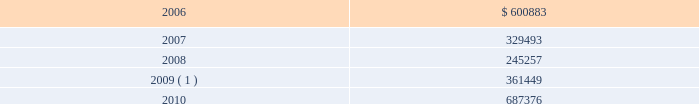During 2005 , we amended our $ 1.0 billion unsecured revolving credit facility to extend its maturity date from march 27 , 2008 to march 27 , 2010 , and reduce the effective interest rate to libor plus 1.0% ( 1.0 % ) and the commitment fee to 0.2% ( 0.2 % ) of the undrawn portion of the facility at december 31 , 2005 .
In addition , in 2005 , we entered into two $ 100.0 million unsecured term loans , due 2010 , at an effective interest rate of libor plus 0.8% ( 0.8 % ) at december 31 , 2005 .
During 2004 , we entered into an eight-year , $ 225.0 million unse- cured term loan , at libor plus 1.75% ( 1.75 % ) , which was amended in 2005 to reduce the effective interest rate to libor plus 1.0% ( 1.0 % ) at december 31 , 2005 .
The liquid yield option 2122 notes and the zero coupon convertible notes are unsecured zero coupon bonds with yields to maturity of 4.875% ( 4.875 % ) and 4.75% ( 4.75 % ) , respectively , due 2021 .
Each liquid yield option 2122 note and zero coupon convertible note was issued at a price of $ 381.63 and $ 391.06 , respectively , and will have a principal amount at maturity of $ 1000 .
Each liquid yield option 2122 note and zero coupon convertible note is convertible at the option of the holder into 11.7152 and 15.6675 shares of common stock , respec- tively , if the market price of our common stock reaches certain lev- els .
These conditions were met at december 31 , 2005 and 2004 for the zero coupon convertible notes and at december 31 , 2004 for the liquid yield option 2122 notes .
Since february 2 , 2005 , we have the right to redeem the liquid yield option 2122 notes and commencing on may 18 , 2006 , we will have the right to redeem the zero coupon con- vertible notes at their accreted values for cash as a whole at any time , or from time to time in part .
Holders may require us to pur- chase any outstanding liquid yield option 2122 notes at their accreted value on february 2 , 2011 and any outstanding zero coupon con- vertible notes at their accreted value on may 18 , 2009 and may 18 , 2014 .
We may choose to pay the purchase price in cash or common stock or a combination thereof .
During 2005 , holders of our liquid yield option 2122 notes and zero coupon convertible notes converted approximately $ 10.4 million and $ 285.0 million , respectively , of the accreted value of these notes into approximately 0.3 million and 9.4 million shares , respec- tively , of our common stock and cash for fractional shares .
In addi- tion , we called for redemption $ 182.3 million of the accreted bal- ance of outstanding liquid yield option 2122 notes .
Most holders of the liquid yield option 2122 notes elected to convert into shares of our common stock , rather than redeem for cash , resulting in the issuance of approximately 4.5 million shares .
During 2005 , we prepaid a total of $ 297.0 million on a term loan secured by a certain celebrity ship and on a variable rate unsecured term loan .
In 1996 , we entered into a $ 264.0 million capital lease to finance splendour of the seas and in 1995 we entered into a $ 260.0 million capital lease to finance legend of the seas .
During 2005 , we paid $ 335.8 million in connection with the exercise of purchase options on these capital lease obligations .
Under certain of our agreements , the contractual interest rate and commitment fee vary with our debt rating .
The unsecured senior notes and senior debentures are not redeemable prior to maturity .
Our debt agreements contain covenants that require us , among other things , to maintain minimum net worth and fixed charge cov- erage ratio and limit our debt to capital ratio .
We are in compliance with all covenants as of december 31 , 2005 .
Following is a schedule of annual maturities on long-term debt as of december 31 , 2005 for each of the next five years ( in thousands ) : .
1 the $ 137.9 million accreted value of the zero coupon convertible notes at december 31 , 2005 is included in year 2009 .
The holders of our zero coupon convertible notes may require us to purchase any notes outstanding at an accreted value of $ 161.7 mil- lion on may 18 , 2009 .
This accreted value was calculated based on the number of notes outstanding at december 31 , 2005 .
We may choose to pay any amounts in cash or common stock or a combination thereof .
Note 6 .
Shareholders 2019 equity on september 25 , 2005 , we announced that we and an investment bank had finalized a forward sale agreement relating to an asr transaction .
As part of the asr transaction , we purchased 5.5 million shares of our common stock from the investment bank at an initial price of $ 45.40 per share .
Total consideration paid to repurchase such shares , including commissions and other fees , was approxi- mately $ 249.1 million and was recorded in shareholders 2019 equity as a component of treasury stock .
The forward sale contract matured in february 2006 .
During the term of the forward sale contract , the investment bank purchased shares of our common stock in the open market to settle its obliga- tion related to the shares borrowed from third parties and sold to us .
Upon settlement of the contract , we received 218089 additional shares of our common stock .
These incremental shares will be recorded in shareholders 2019 equity as a component of treasury stock in the first quarter of 2006 .
Our employee stock purchase plan ( 201cespp 201d ) , which has been in effect since january 1 , 1994 , facilitates the purchase by employees of up to 800000 shares of common stock .
Offerings to employees are made on a quarterly basis .
Subject to certain limitations , the pur- chase price for each share of common stock is equal to 90% ( 90 % ) of the average of the market prices of the common stock as reported on the new york stock exchange on the first business day of the pur- chase period and the last business day of each month of the pur- chase period .
Shares of common stock of 14476 , 13281 and 21280 38 royal caribbean cruises ltd .
Notes to the consolidated financial statements ( continued ) .
As of december 31 , 2005 what was the ratio of the annual maturities on long-term debt in 2006 to 2007? 
Computations: (600883 / 329493)
Answer: 1.82366. 